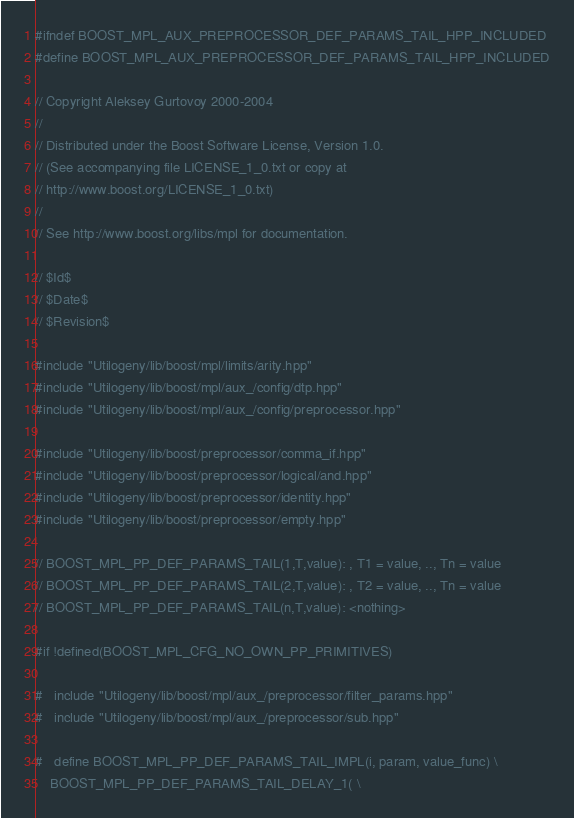Convert code to text. <code><loc_0><loc_0><loc_500><loc_500><_C++_>
#ifndef BOOST_MPL_AUX_PREPROCESSOR_DEF_PARAMS_TAIL_HPP_INCLUDED
#define BOOST_MPL_AUX_PREPROCESSOR_DEF_PARAMS_TAIL_HPP_INCLUDED

// Copyright Aleksey Gurtovoy 2000-2004
//
// Distributed under the Boost Software License, Version 1.0. 
// (See accompanying file LICENSE_1_0.txt or copy at 
// http://www.boost.org/LICENSE_1_0.txt)
//
// See http://www.boost.org/libs/mpl for documentation.

// $Id$
// $Date$
// $Revision$

#include "Utilogeny/lib/boost/mpl/limits/arity.hpp"
#include "Utilogeny/lib/boost/mpl/aux_/config/dtp.hpp"
#include "Utilogeny/lib/boost/mpl/aux_/config/preprocessor.hpp"

#include "Utilogeny/lib/boost/preprocessor/comma_if.hpp"
#include "Utilogeny/lib/boost/preprocessor/logical/and.hpp"
#include "Utilogeny/lib/boost/preprocessor/identity.hpp"
#include "Utilogeny/lib/boost/preprocessor/empty.hpp"

// BOOST_MPL_PP_DEF_PARAMS_TAIL(1,T,value): , T1 = value, .., Tn = value
// BOOST_MPL_PP_DEF_PARAMS_TAIL(2,T,value): , T2 = value, .., Tn = value
// BOOST_MPL_PP_DEF_PARAMS_TAIL(n,T,value): <nothing>

#if !defined(BOOST_MPL_CFG_NO_OWN_PP_PRIMITIVES)

#   include "Utilogeny/lib/boost/mpl/aux_/preprocessor/filter_params.hpp"
#   include "Utilogeny/lib/boost/mpl/aux_/preprocessor/sub.hpp"

#   define BOOST_MPL_PP_DEF_PARAMS_TAIL_IMPL(i, param, value_func) \
    BOOST_MPL_PP_DEF_PARAMS_TAIL_DELAY_1( \</code> 